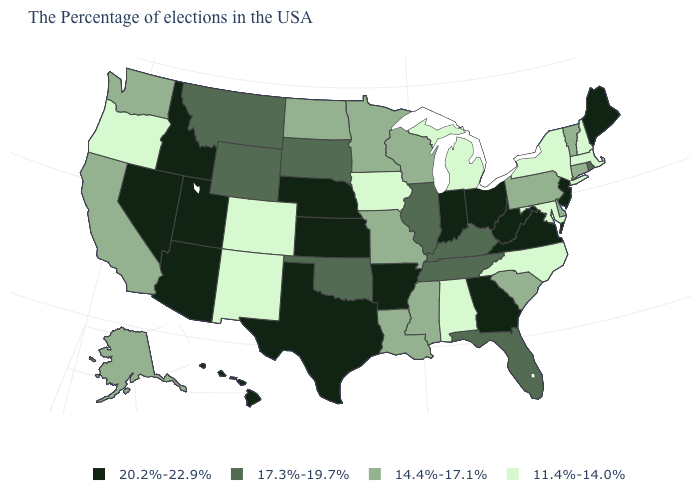What is the value of Vermont?
Be succinct. 14.4%-17.1%. Name the states that have a value in the range 14.4%-17.1%?
Give a very brief answer. Vermont, Connecticut, Delaware, Pennsylvania, South Carolina, Wisconsin, Mississippi, Louisiana, Missouri, Minnesota, North Dakota, California, Washington, Alaska. What is the value of Connecticut?
Short answer required. 14.4%-17.1%. Which states have the lowest value in the USA?
Keep it brief. Massachusetts, New Hampshire, New York, Maryland, North Carolina, Michigan, Alabama, Iowa, Colorado, New Mexico, Oregon. Does Rhode Island have a higher value than Illinois?
Be succinct. No. Name the states that have a value in the range 11.4%-14.0%?
Be succinct. Massachusetts, New Hampshire, New York, Maryland, North Carolina, Michigan, Alabama, Iowa, Colorado, New Mexico, Oregon. What is the value of North Dakota?
Give a very brief answer. 14.4%-17.1%. Name the states that have a value in the range 14.4%-17.1%?
Be succinct. Vermont, Connecticut, Delaware, Pennsylvania, South Carolina, Wisconsin, Mississippi, Louisiana, Missouri, Minnesota, North Dakota, California, Washington, Alaska. Does Nevada have the same value as Utah?
Be succinct. Yes. What is the value of Idaho?
Give a very brief answer. 20.2%-22.9%. Does Texas have the highest value in the USA?
Short answer required. Yes. How many symbols are there in the legend?
Be succinct. 4. Does Ohio have the same value as North Carolina?
Short answer required. No. Does Wyoming have a higher value than Arizona?
Quick response, please. No. 